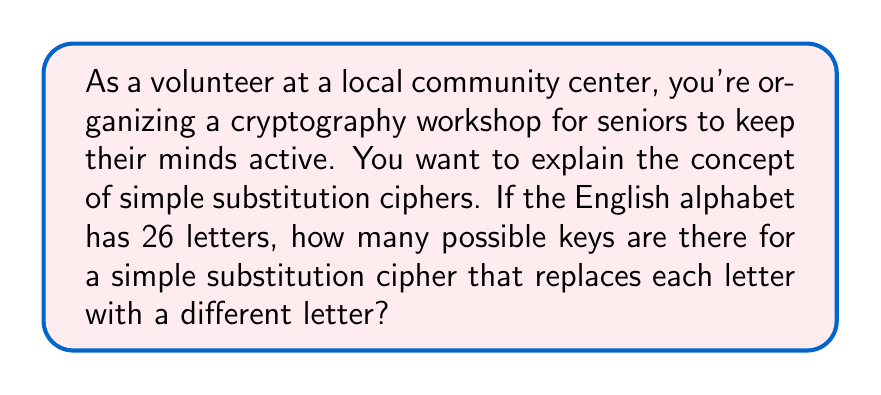Solve this math problem. Let's approach this step-by-step:

1) In a simple substitution cipher, each letter of the alphabet is replaced by another letter, and no two letters can be replaced by the same letter.

2) For the first letter of the alphabet, we have 26 choices to replace it with.

3) For the second letter, we now have 25 choices, as one letter has already been used.

4) For the third letter, we have 24 choices, and so on.

5) This continues until we reach the last letter, where we have only 1 choice left.

6) This scenario is a perfect application of the multiplication principle in combinatorics.

7) The total number of possible keys is therefore:

   $$26 \times 25 \times 24 \times 23 \times ... \times 2 \times 1$$

8) This is the definition of 26 factorial, denoted as 26!

9) We can calculate this:
   
   $$26! = 403,291,461,126,605,635,584,000,000$$

This incredibly large number demonstrates why simple substitution ciphers, despite being easy to understand, can be quite secure if the message is short enough to prevent frequency analysis.
Answer: $26!$ or 403,291,461,126,605,635,584,000,000 